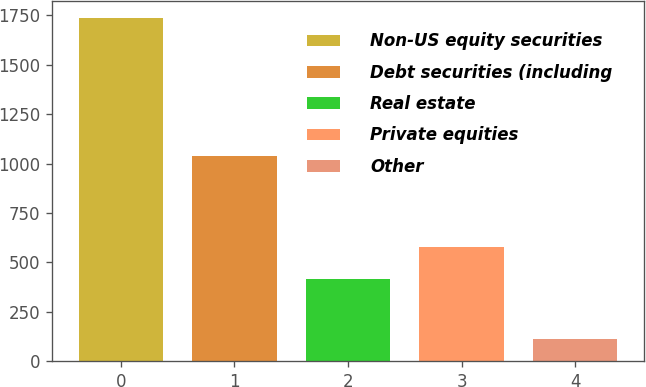Convert chart to OTSL. <chart><loc_0><loc_0><loc_500><loc_500><bar_chart><fcel>Non-US equity securities<fcel>Debt securities (including<fcel>Real estate<fcel>Private equities<fcel>Other<nl><fcel>1737<fcel>1040<fcel>414<fcel>576.3<fcel>114<nl></chart> 